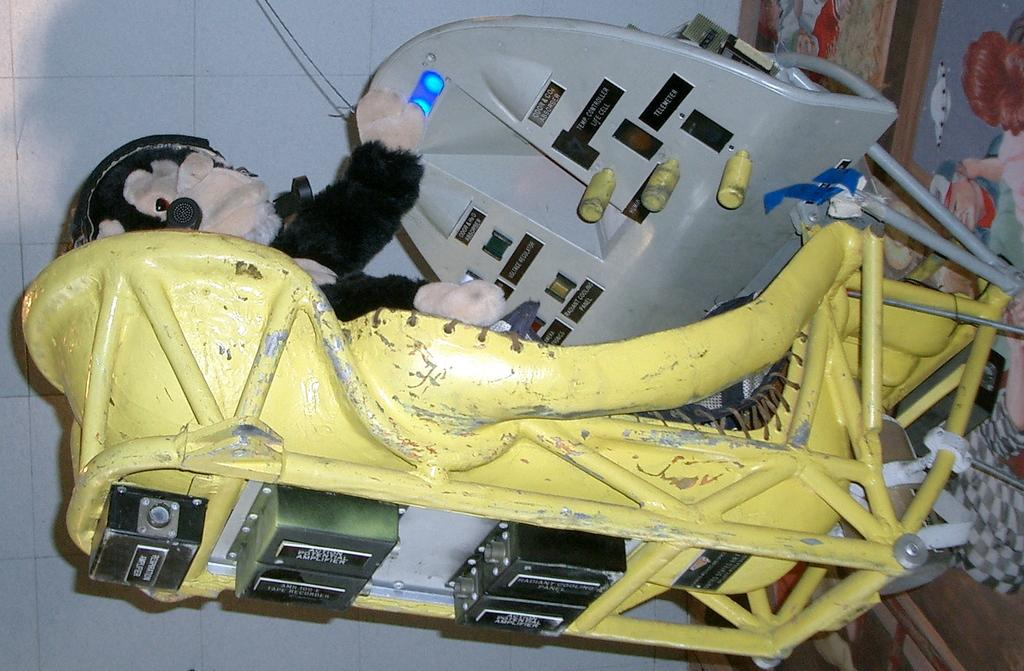What type of chairs are in the image? There are metal chairs in the image. What type of object can be seen besides the chairs? There is a soft toy in the image. What can be seen in the background of the image? There is a wall visible in the image. What is on the floor in the image? There is a carpet on the floor in the image. What type of butter is being spread on the wall in the image? There is no butter present in the image, and the wall is not being used for spreading anything. 